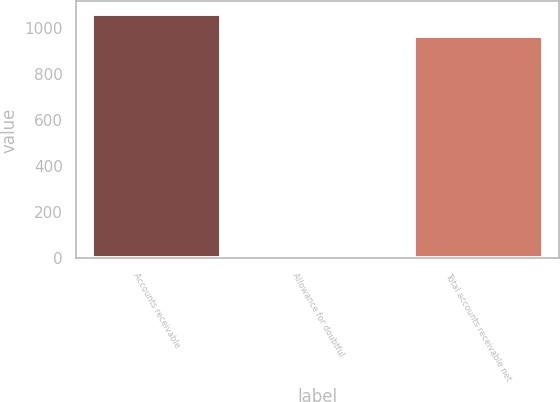Convert chart to OTSL. <chart><loc_0><loc_0><loc_500><loc_500><bar_chart><fcel>Accounts receivable<fcel>Allowance for doubtful<fcel>Total accounts receivable net<nl><fcel>1064.8<fcel>4<fcel>968<nl></chart> 